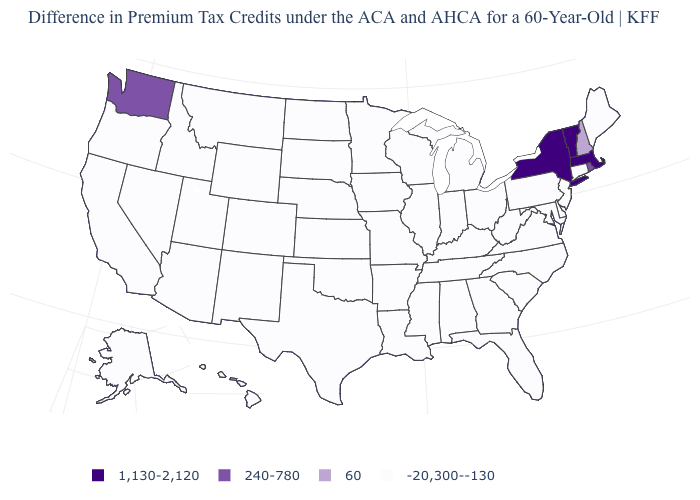What is the highest value in the USA?
Quick response, please. 1,130-2,120. Which states have the lowest value in the USA?
Concise answer only. Alabama, Alaska, Arizona, Arkansas, California, Colorado, Connecticut, Delaware, Florida, Georgia, Hawaii, Idaho, Illinois, Indiana, Iowa, Kansas, Kentucky, Louisiana, Maine, Maryland, Michigan, Minnesota, Mississippi, Missouri, Montana, Nebraska, Nevada, New Jersey, New Mexico, North Carolina, North Dakota, Ohio, Oklahoma, Oregon, Pennsylvania, South Carolina, South Dakota, Tennessee, Texas, Utah, Virginia, West Virginia, Wisconsin, Wyoming. What is the value of Maine?
Write a very short answer. -20,300--130. What is the value of South Dakota?
Short answer required. -20,300--130. What is the value of South Carolina?
Write a very short answer. -20,300--130. Does the first symbol in the legend represent the smallest category?
Write a very short answer. No. Which states hav the highest value in the South?
Keep it brief. Alabama, Arkansas, Delaware, Florida, Georgia, Kentucky, Louisiana, Maryland, Mississippi, North Carolina, Oklahoma, South Carolina, Tennessee, Texas, Virginia, West Virginia. What is the value of Utah?
Be succinct. -20,300--130. Name the states that have a value in the range 60?
Answer briefly. New Hampshire. What is the value of Washington?
Answer briefly. 240-780. Is the legend a continuous bar?
Concise answer only. No. Does Virginia have the highest value in the USA?
Be succinct. No. What is the highest value in the USA?
Give a very brief answer. 1,130-2,120. Among the states that border New Mexico , which have the lowest value?
Keep it brief. Arizona, Colorado, Oklahoma, Texas, Utah. What is the value of Alaska?
Be succinct. -20,300--130. 